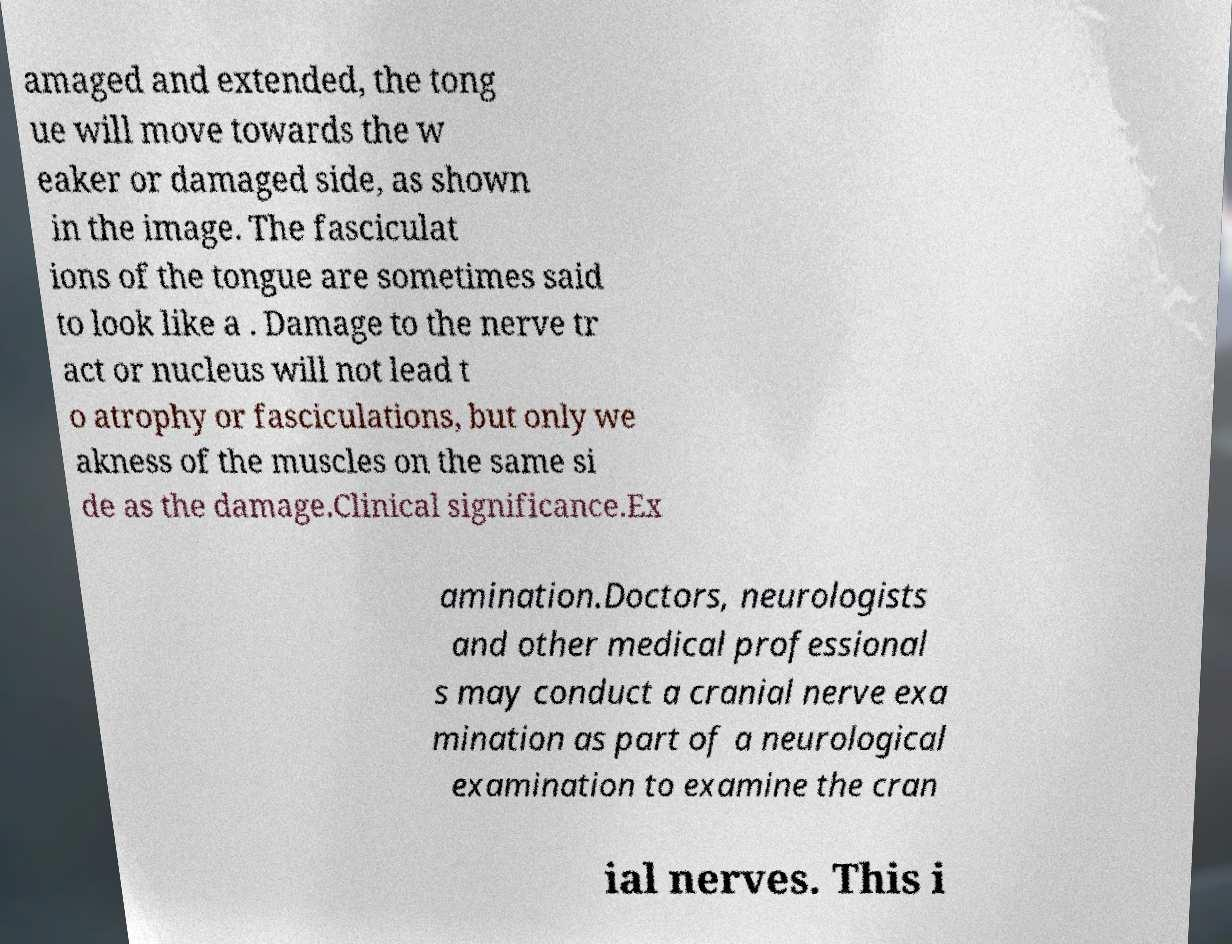Please identify and transcribe the text found in this image. amaged and extended, the tong ue will move towards the w eaker or damaged side, as shown in the image. The fasciculat ions of the tongue are sometimes said to look like a . Damage to the nerve tr act or nucleus will not lead t o atrophy or fasciculations, but only we akness of the muscles on the same si de as the damage.Clinical significance.Ex amination.Doctors, neurologists and other medical professional s may conduct a cranial nerve exa mination as part of a neurological examination to examine the cran ial nerves. This i 